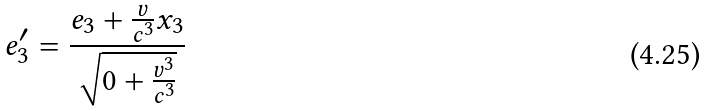Convert formula to latex. <formula><loc_0><loc_0><loc_500><loc_500>e _ { 3 } ^ { \prime } = \frac { e _ { 3 } + \frac { v } { c ^ { 3 } } x _ { 3 } } { \sqrt { 0 + \frac { v ^ { 3 } } { c ^ { 3 } } } }</formula> 